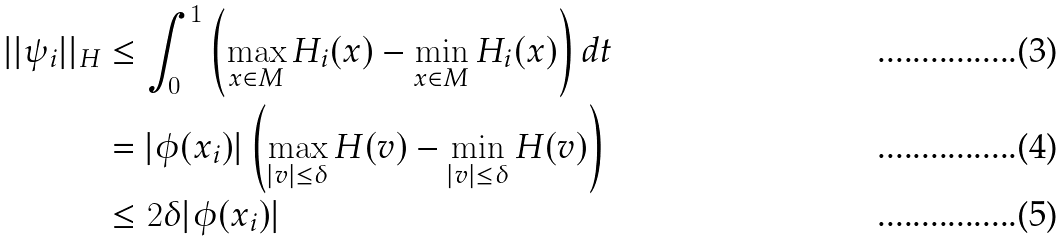<formula> <loc_0><loc_0><loc_500><loc_500>| | \psi _ { i } | | _ { H } & \leq \int _ { 0 } ^ { 1 } \left ( \max _ { x \in M } H _ { i } ( x ) - \min _ { x \in M } H _ { i } ( x ) \right ) d t \\ & = | \phi ( x _ { i } ) | \left ( \max _ { | v | \leq \delta } H ( v ) - \min _ { | v | \leq \delta } H ( v ) \right ) \\ & \leq 2 \delta | \phi ( x _ { i } ) |</formula> 